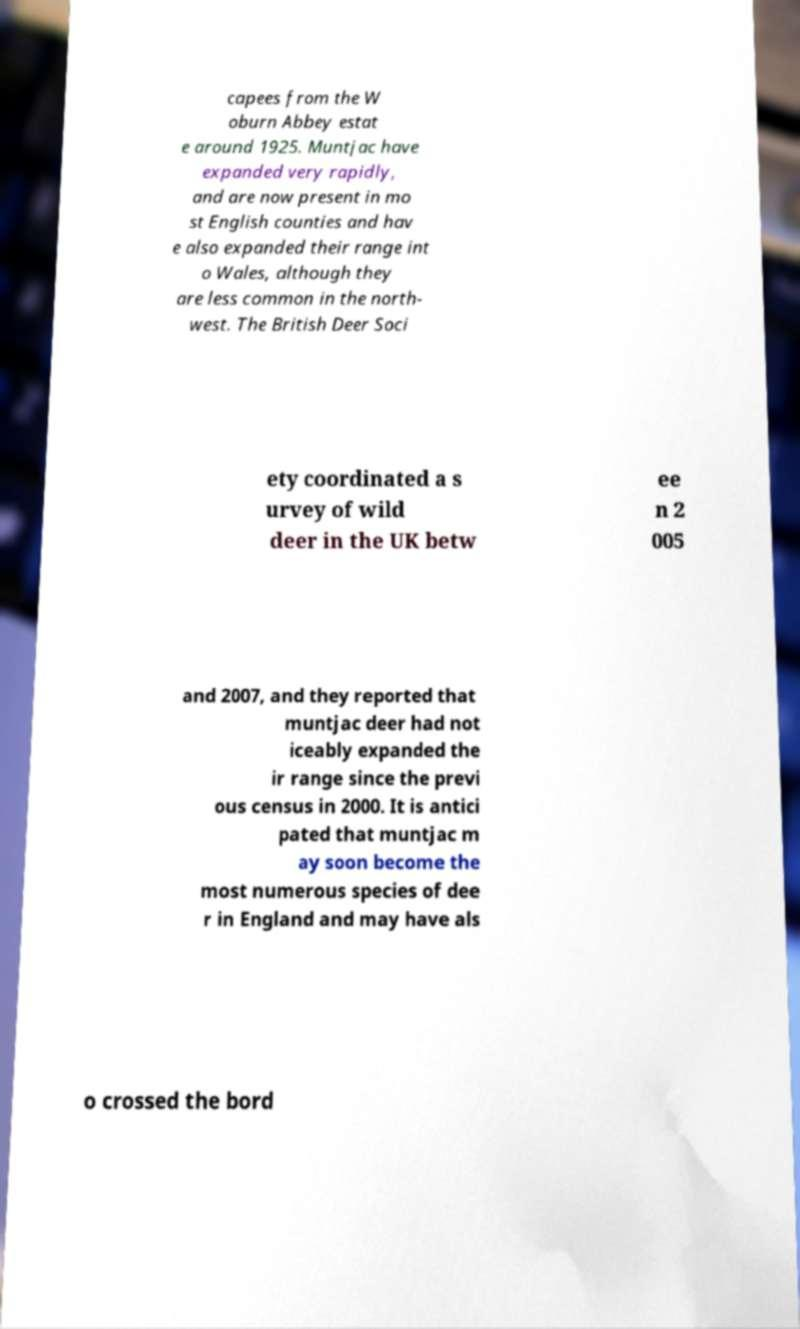Can you read and provide the text displayed in the image?This photo seems to have some interesting text. Can you extract and type it out for me? capees from the W oburn Abbey estat e around 1925. Muntjac have expanded very rapidly, and are now present in mo st English counties and hav e also expanded their range int o Wales, although they are less common in the north- west. The British Deer Soci ety coordinated a s urvey of wild deer in the UK betw ee n 2 005 and 2007, and they reported that muntjac deer had not iceably expanded the ir range since the previ ous census in 2000. It is antici pated that muntjac m ay soon become the most numerous species of dee r in England and may have als o crossed the bord 